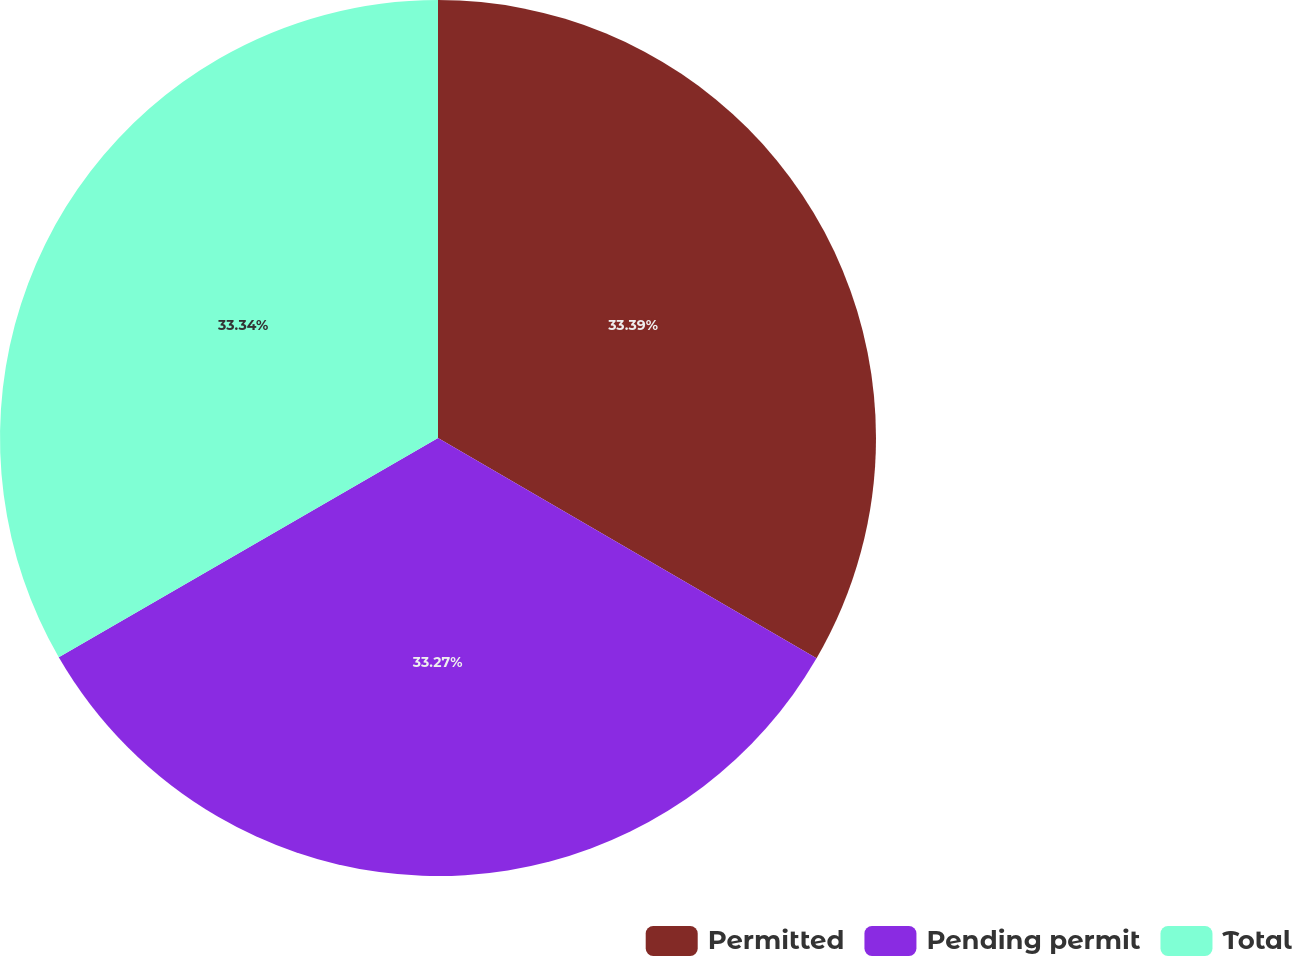<chart> <loc_0><loc_0><loc_500><loc_500><pie_chart><fcel>Permitted<fcel>Pending permit<fcel>Total<nl><fcel>33.39%<fcel>33.27%<fcel>33.34%<nl></chart> 